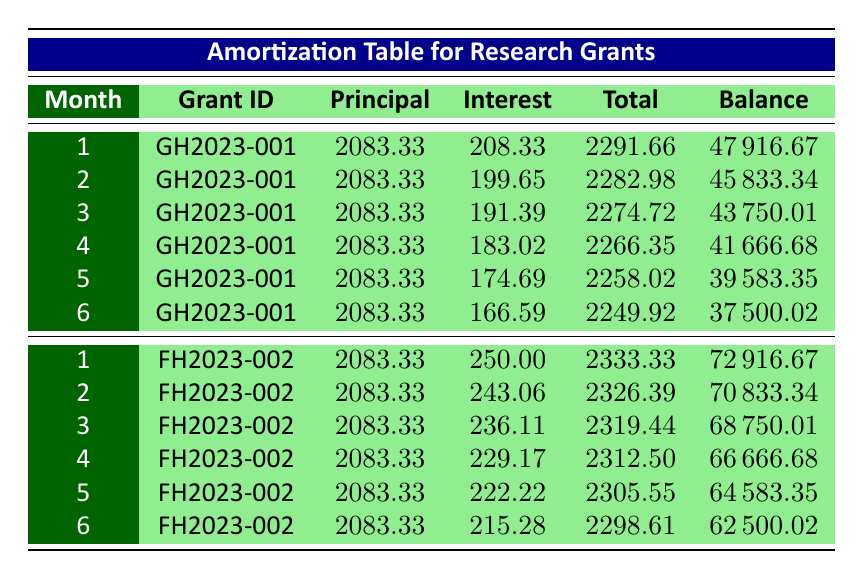What is the total principal payment made in the first month for grant GH2023-001? In the first month of grant GH2023-001, the principal payment is listed as 2083.33.
Answer: 2083.33 What is the remaining balance after the second payment for grant FH2023-002? The remaining balance after the second payment for grant FH2023-002 is stated as 70833.34.
Answer: 70833.34 How much total payment was made in the first month of grant FH2023-002? The total payment in the first month for grant FH2023-002 is listed as 2333.33.
Answer: 2333.33 Is the interest payment in the first month for grant GH2023-001 greater than that for grant FH2023-002? The interest payment for grant GH2023-001 in the first month is 208.33, while for grant FH2023-002, it is 250.00. Thus, 208.33 < 250.00, so the statement is false.
Answer: No What is the average total payment made in the first six months for grant GH2023-001? The total payments for the first six months for grant GH2023-001 are 2291.66, 2282.98, 2274.72, 2266.35, 2258.02, and 2249.92. Their sum is (2291.66 + 2282.98 + 2274.72 + 2266.35 + 2258.02 + 2249.92) = 13663.65, and there are 6 payments, so the average is 13663.65 / 6 = 2277.28.
Answer: 2277.28 What is the total interest payment for the first three months of grant FH2023-002? The interest payments for the first three months of grant FH2023-002 are 250.00, 243.06, and 236.11. Adding these gives (250.00 + 243.06 + 236.11) = 729.17.
Answer: 729.17 How much principal is left after the third month of grant GH2023-001? The remaining balance after the third month for grant GH2023-001 is reported as 43750.01.
Answer: 43750.01 Is the total payment in month six for grant GH2023-001 greater than that in month six for grant FH2023-002? The total payment in month six for grant GH2023-001 is 2249.92, and for grant FH2023-002 it is 2298.61. Thus, 2249.92 < 2298.61, so the statement is false.
Answer: No 